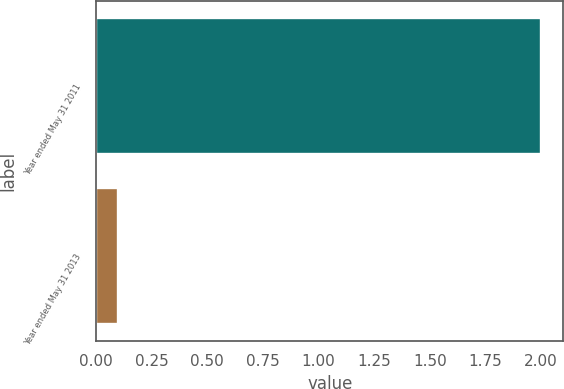<chart> <loc_0><loc_0><loc_500><loc_500><bar_chart><fcel>Year ended May 31 2011<fcel>Year ended May 31 2013<nl><fcel>2<fcel>0.1<nl></chart> 